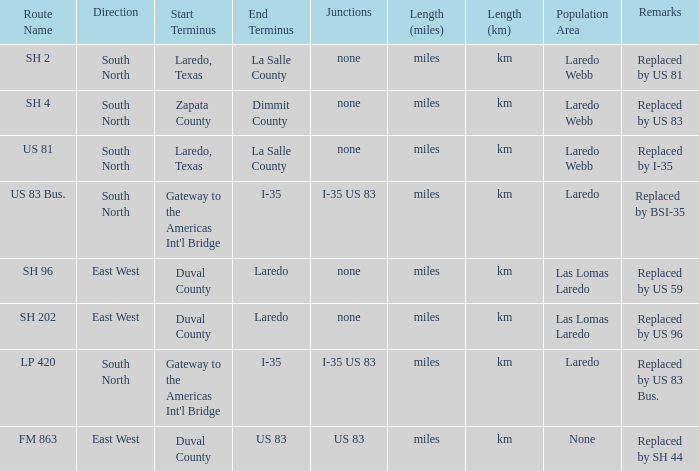What unit of length is being used for the route with "replaced by us 81" in their remarks section? Miles (km). 